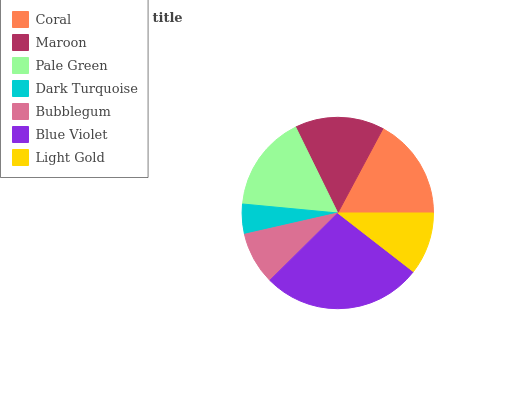Is Dark Turquoise the minimum?
Answer yes or no. Yes. Is Blue Violet the maximum?
Answer yes or no. Yes. Is Maroon the minimum?
Answer yes or no. No. Is Maroon the maximum?
Answer yes or no. No. Is Coral greater than Maroon?
Answer yes or no. Yes. Is Maroon less than Coral?
Answer yes or no. Yes. Is Maroon greater than Coral?
Answer yes or no. No. Is Coral less than Maroon?
Answer yes or no. No. Is Maroon the high median?
Answer yes or no. Yes. Is Maroon the low median?
Answer yes or no. Yes. Is Light Gold the high median?
Answer yes or no. No. Is Dark Turquoise the low median?
Answer yes or no. No. 